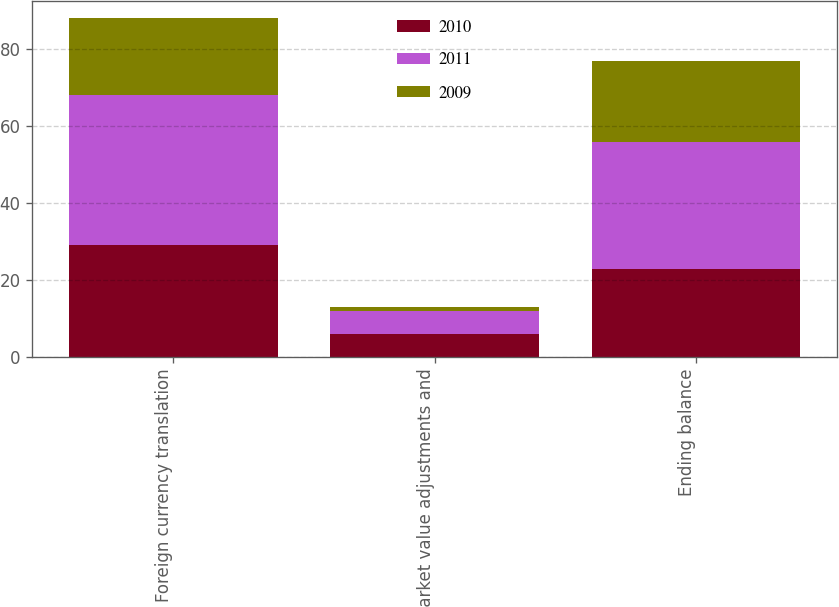Convert chart. <chart><loc_0><loc_0><loc_500><loc_500><stacked_bar_chart><ecel><fcel>Foreign currency translation<fcel>Market value adjustments and<fcel>Ending balance<nl><fcel>2010<fcel>29<fcel>6<fcel>23<nl><fcel>2011<fcel>39<fcel>6<fcel>33<nl><fcel>2009<fcel>20<fcel>1<fcel>21<nl></chart> 